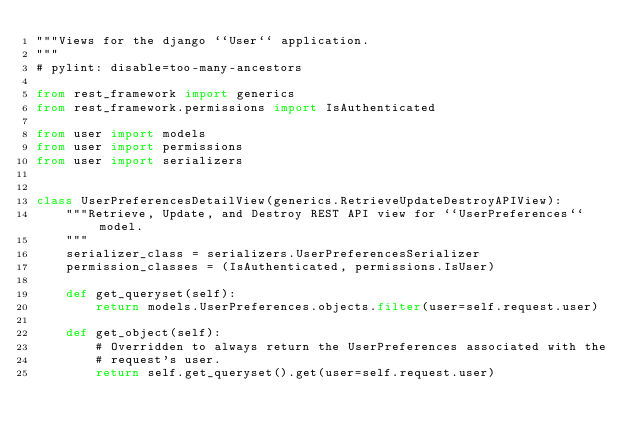<code> <loc_0><loc_0><loc_500><loc_500><_Python_>"""Views for the django ``User`` application.
"""
# pylint: disable=too-many-ancestors

from rest_framework import generics
from rest_framework.permissions import IsAuthenticated

from user import models
from user import permissions
from user import serializers


class UserPreferencesDetailView(generics.RetrieveUpdateDestroyAPIView):
    """Retrieve, Update, and Destroy REST API view for ``UserPreferences``model.
    """
    serializer_class = serializers.UserPreferencesSerializer
    permission_classes = (IsAuthenticated, permissions.IsUser)

    def get_queryset(self):
        return models.UserPreferences.objects.filter(user=self.request.user)

    def get_object(self):
        # Overridden to always return the UserPreferences associated with the
        # request's user.
        return self.get_queryset().get(user=self.request.user)
</code> 